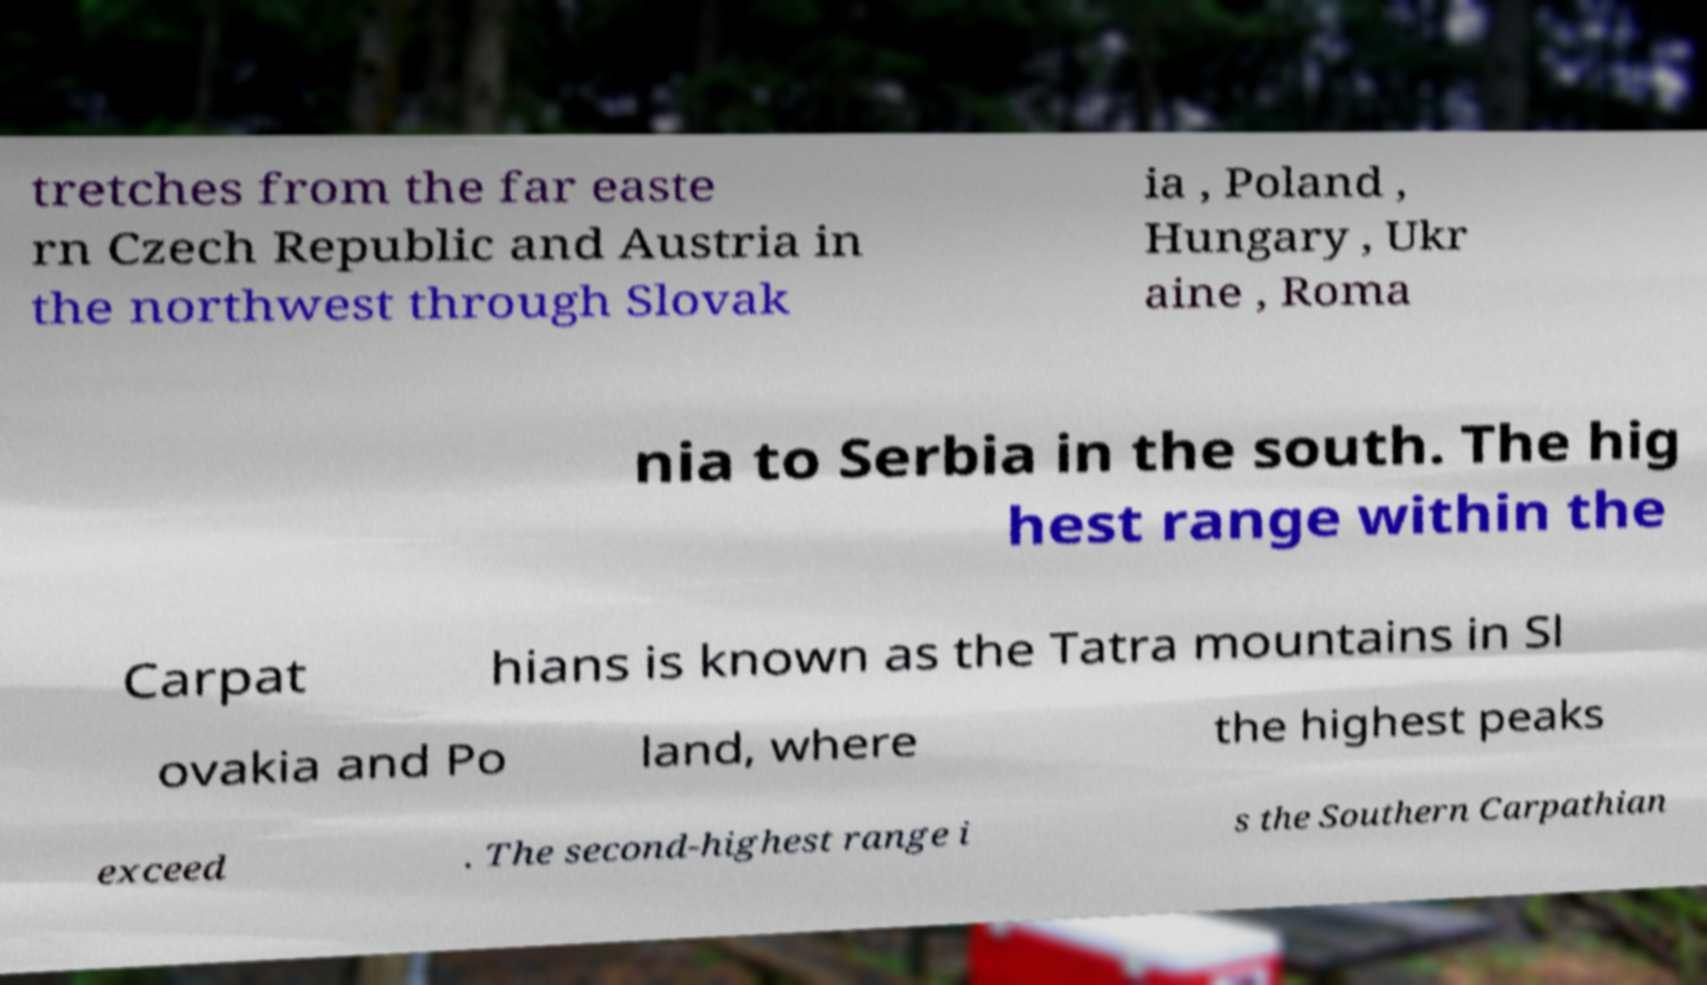Could you extract and type out the text from this image? tretches from the far easte rn Czech Republic and Austria in the northwest through Slovak ia , Poland , Hungary , Ukr aine , Roma nia to Serbia in the south. The hig hest range within the Carpat hians is known as the Tatra mountains in Sl ovakia and Po land, where the highest peaks exceed . The second-highest range i s the Southern Carpathian 